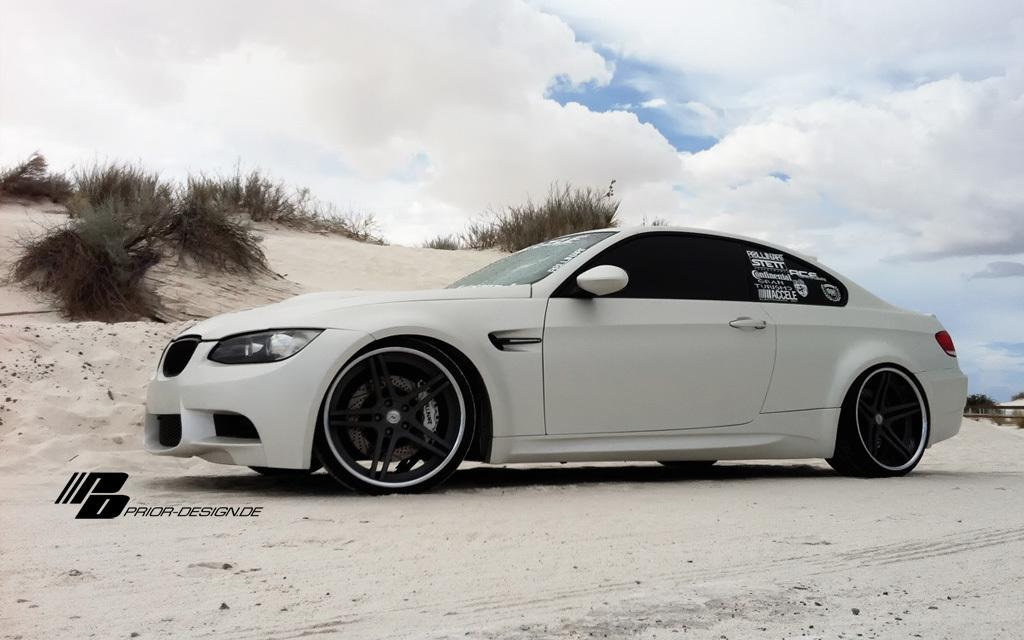What is the main subject of the image? There is a car in the image. Where is the car located? The car is on the sand. What type of vegetation can be seen in the image? There is grass visible in the image behind the car. What type of growth can be seen on the car in the image? There is no growth visible on the car in the image. What offer is being made by the car in the image? The car is not making any offer in the image; it is an inanimate object. 